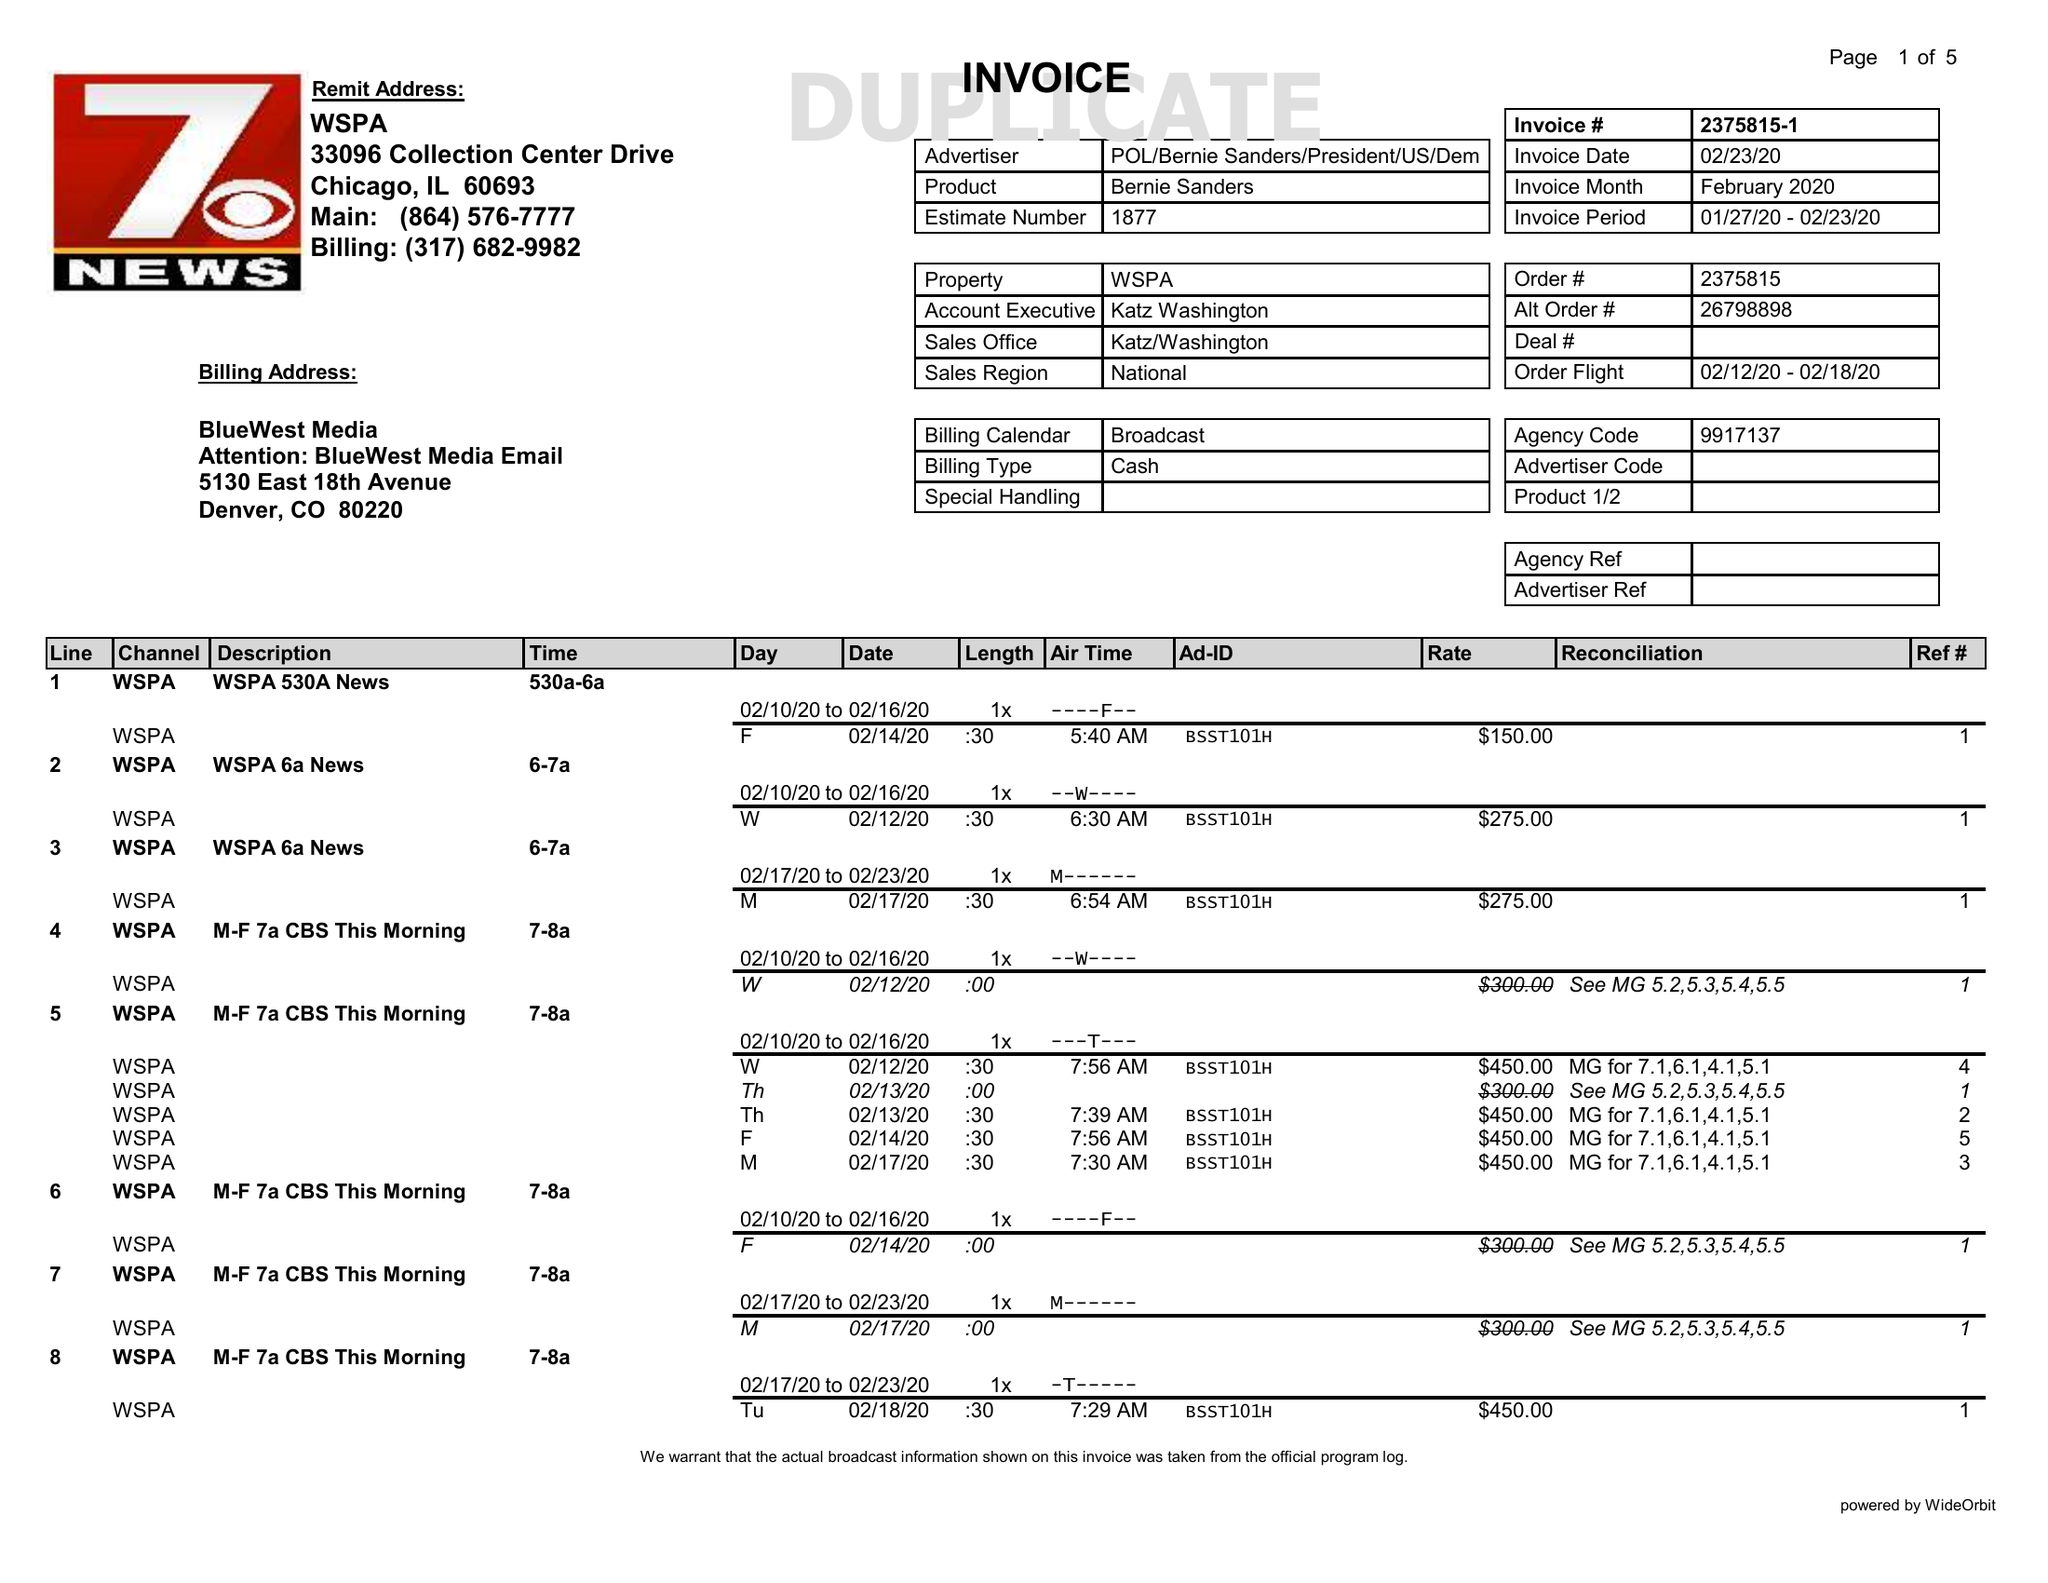What is the value for the advertiser?
Answer the question using a single word or phrase. POL/BERNIESANDERS/PRESIDENT/US/DEM 